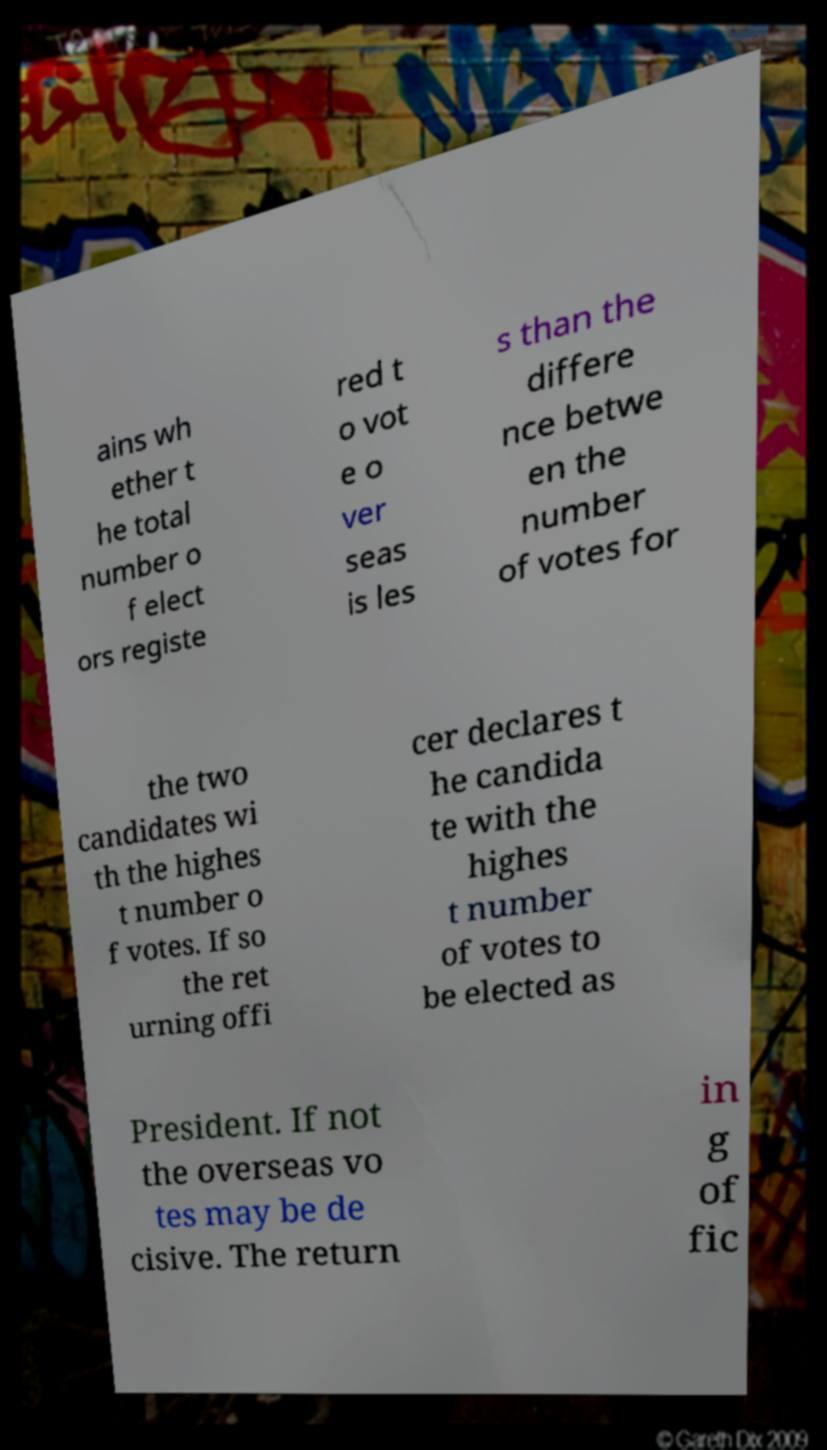I need the written content from this picture converted into text. Can you do that? ains wh ether t he total number o f elect ors registe red t o vot e o ver seas is les s than the differe nce betwe en the number of votes for the two candidates wi th the highes t number o f votes. If so the ret urning offi cer declares t he candida te with the highes t number of votes to be elected as President. If not the overseas vo tes may be de cisive. The return in g of fic 